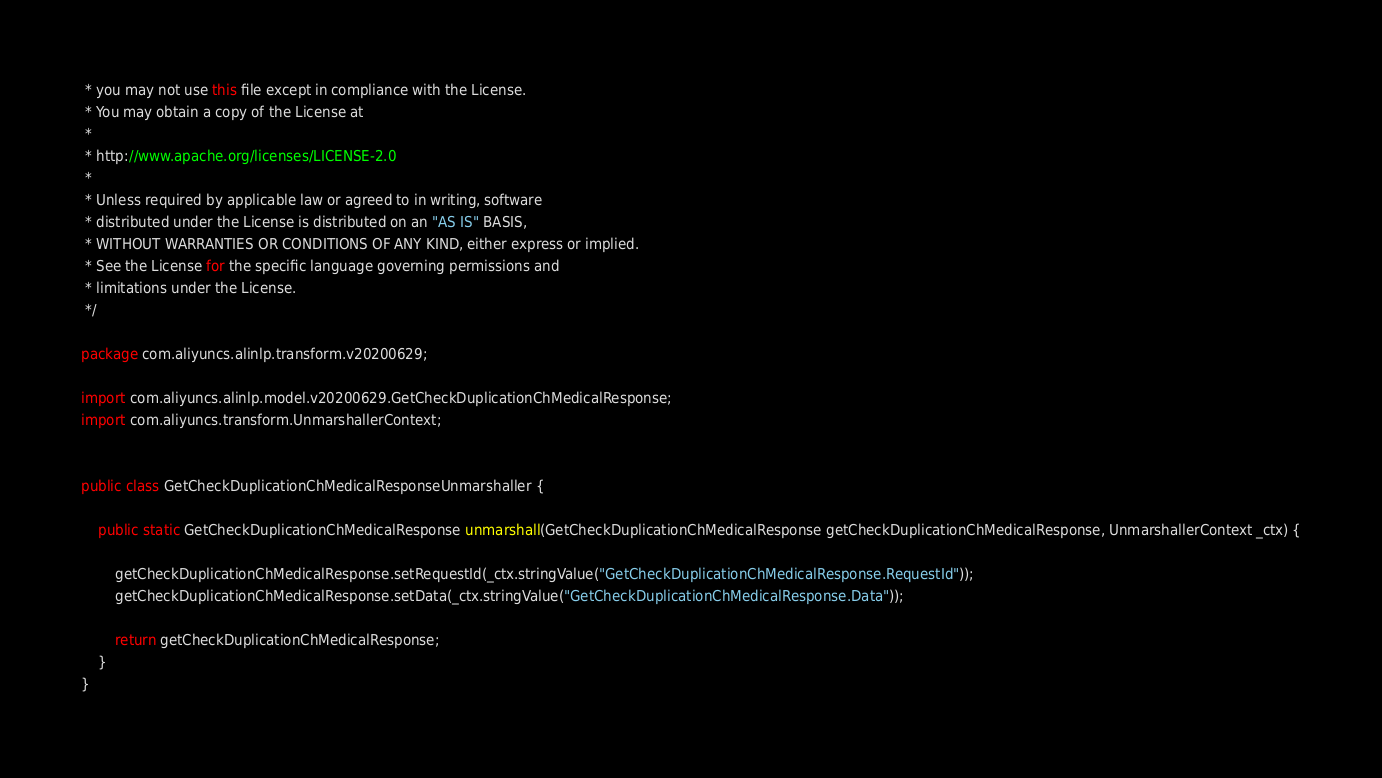<code> <loc_0><loc_0><loc_500><loc_500><_Java_> * you may not use this file except in compliance with the License.
 * You may obtain a copy of the License at
 *
 * http://www.apache.org/licenses/LICENSE-2.0
 *
 * Unless required by applicable law or agreed to in writing, software
 * distributed under the License is distributed on an "AS IS" BASIS,
 * WITHOUT WARRANTIES OR CONDITIONS OF ANY KIND, either express or implied.
 * See the License for the specific language governing permissions and
 * limitations under the License.
 */

package com.aliyuncs.alinlp.transform.v20200629;

import com.aliyuncs.alinlp.model.v20200629.GetCheckDuplicationChMedicalResponse;
import com.aliyuncs.transform.UnmarshallerContext;


public class GetCheckDuplicationChMedicalResponseUnmarshaller {

	public static GetCheckDuplicationChMedicalResponse unmarshall(GetCheckDuplicationChMedicalResponse getCheckDuplicationChMedicalResponse, UnmarshallerContext _ctx) {
		
		getCheckDuplicationChMedicalResponse.setRequestId(_ctx.stringValue("GetCheckDuplicationChMedicalResponse.RequestId"));
		getCheckDuplicationChMedicalResponse.setData(_ctx.stringValue("GetCheckDuplicationChMedicalResponse.Data"));
	 
	 	return getCheckDuplicationChMedicalResponse;
	}
}</code> 